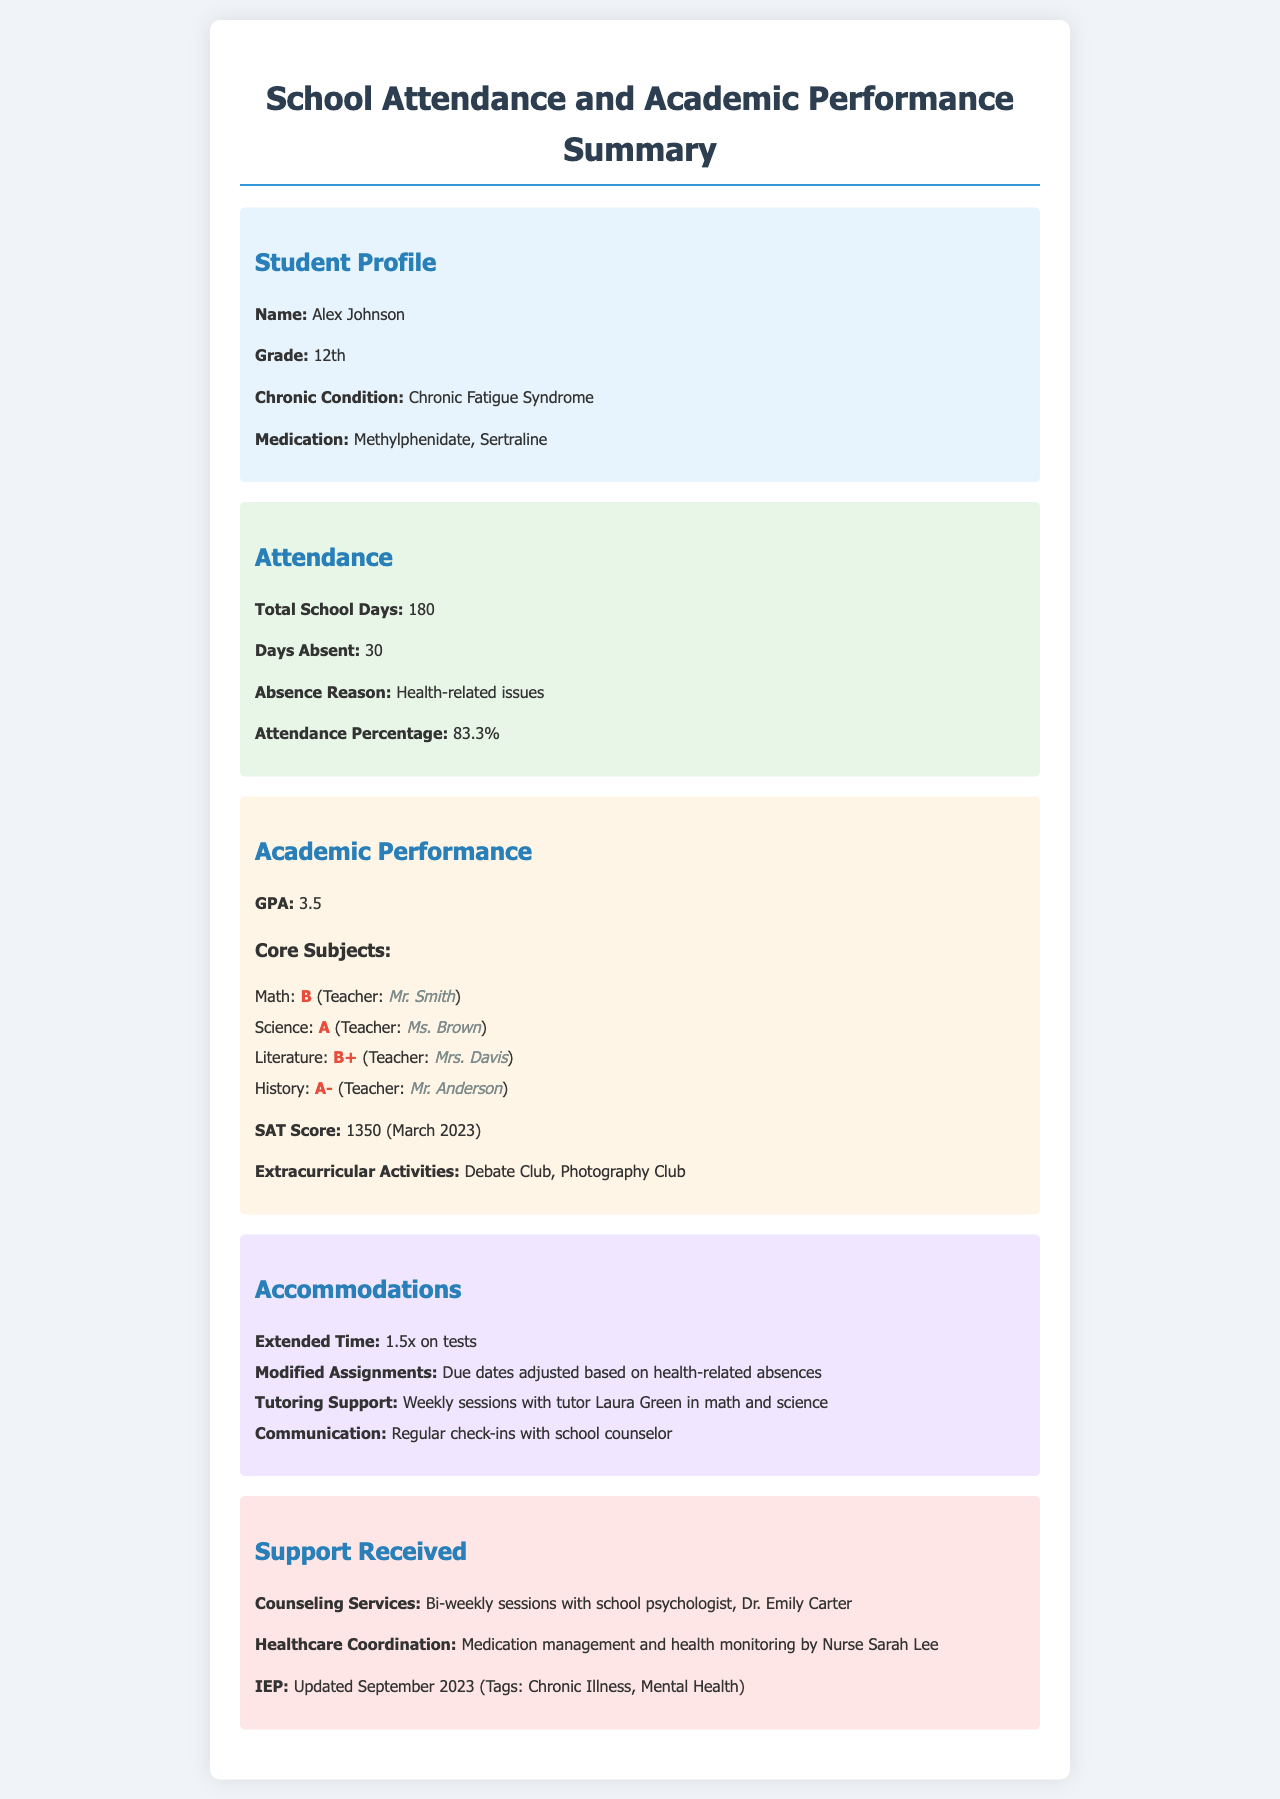What is the student's name? The student's name is provided in the profile section of the document.
Answer: Alex Johnson How many days was the student absent? The number of days absent can be found in the attendance section of the document.
Answer: 30 What is the student's GPA? The GPA is listed under the academic performance section of the document.
Answer: 3.5 What subjects received a grade of A? The subjects with an A grade can be identified by reviewing the academic performance section's core subjects list.
Answer: Science, History How often does the student receive counseling services? The frequency of counseling services is stated in the support received section of the document.
Answer: Bi-weekly What medication is listed for the student's chronic condition? The medication for the chronic condition is mentioned in the profile section of the document.
Answer: Methylphenidate, Sertraline What accommodations are provided for testing? The accommodations for testing are specified in the accommodations section of the document.
Answer: Extended Time: 1.5x on tests Who oversees healthcare coordination for the student? The individual responsible for healthcare coordination is mentioned in the support received section of the document.
Answer: Nurse Sarah Lee When was the IEP updated? The date of the IEP update can be found in the support received section of the document.
Answer: September 2023 